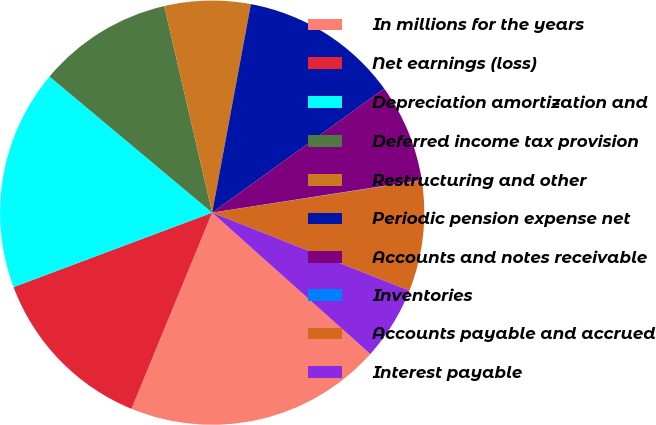Convert chart to OTSL. <chart><loc_0><loc_0><loc_500><loc_500><pie_chart><fcel>In millions for the years<fcel>Net earnings (loss)<fcel>Depreciation amortization and<fcel>Deferred income tax provision<fcel>Restructuring and other<fcel>Periodic pension expense net<fcel>Accounts and notes receivable<fcel>Inventories<fcel>Accounts payable and accrued<fcel>Interest payable<nl><fcel>19.6%<fcel>13.08%<fcel>16.8%<fcel>10.28%<fcel>6.55%<fcel>12.14%<fcel>7.48%<fcel>0.03%<fcel>8.42%<fcel>5.62%<nl></chart> 